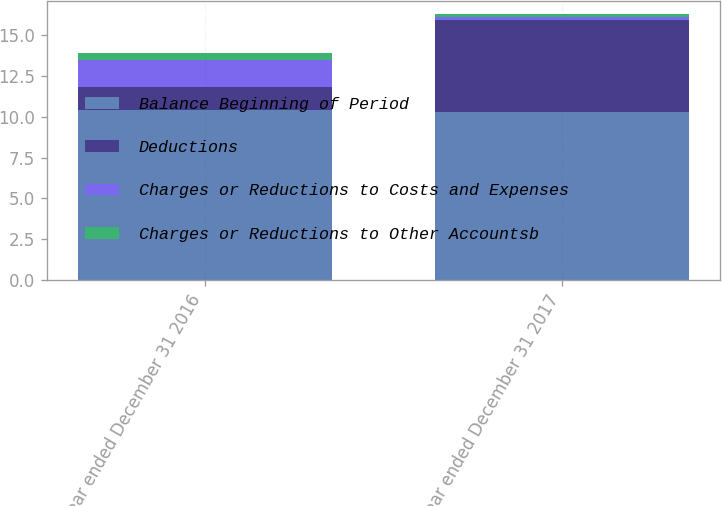Convert chart to OTSL. <chart><loc_0><loc_0><loc_500><loc_500><stacked_bar_chart><ecel><fcel>Year ended December 31 2016<fcel>Year ended December 31 2017<nl><fcel>Balance Beginning of Period<fcel>10.4<fcel>10.3<nl><fcel>Deductions<fcel>1.4<fcel>5.6<nl><fcel>Charges or Reductions to Costs and Expenses<fcel>1.7<fcel>0.2<nl><fcel>Charges or Reductions to Other Accountsb<fcel>0.4<fcel>0.2<nl></chart> 